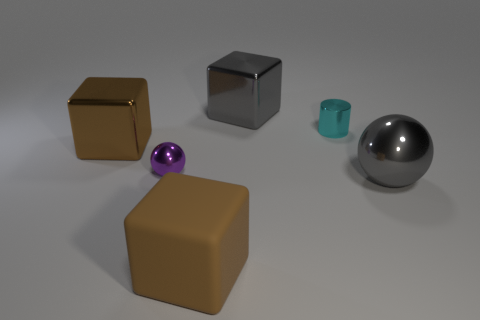What number of blocks have the same color as the tiny shiny ball?
Provide a succinct answer. 0. Is there anything else that is the same shape as the brown metal thing?
Offer a very short reply. Yes. How many cylinders are large gray objects or small cyan things?
Your response must be concise. 1. There is a large cube that is to the left of the big matte object; what is its color?
Ensure brevity in your answer.  Brown. What shape is the cyan metallic thing that is the same size as the purple sphere?
Give a very brief answer. Cylinder. There is a big brown matte cube; what number of balls are on the left side of it?
Offer a terse response. 1. How many objects are tiny red matte cylinders or tiny cyan metallic cylinders?
Your response must be concise. 1. The shiny thing that is on the right side of the large brown rubber cube and left of the cyan cylinder has what shape?
Offer a terse response. Cube. How many yellow metallic objects are there?
Provide a succinct answer. 0. What is the color of the other big sphere that is made of the same material as the purple ball?
Make the answer very short. Gray. 